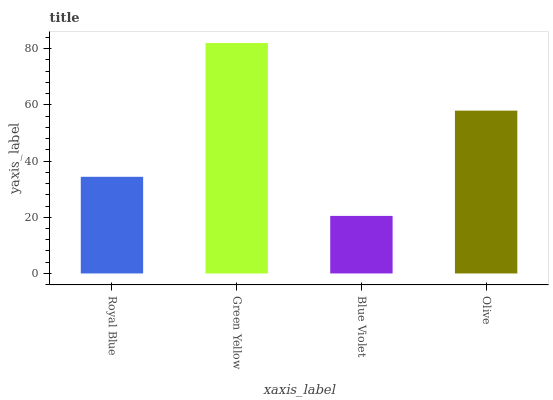Is Blue Violet the minimum?
Answer yes or no. Yes. Is Green Yellow the maximum?
Answer yes or no. Yes. Is Green Yellow the minimum?
Answer yes or no. No. Is Blue Violet the maximum?
Answer yes or no. No. Is Green Yellow greater than Blue Violet?
Answer yes or no. Yes. Is Blue Violet less than Green Yellow?
Answer yes or no. Yes. Is Blue Violet greater than Green Yellow?
Answer yes or no. No. Is Green Yellow less than Blue Violet?
Answer yes or no. No. Is Olive the high median?
Answer yes or no. Yes. Is Royal Blue the low median?
Answer yes or no. Yes. Is Royal Blue the high median?
Answer yes or no. No. Is Green Yellow the low median?
Answer yes or no. No. 